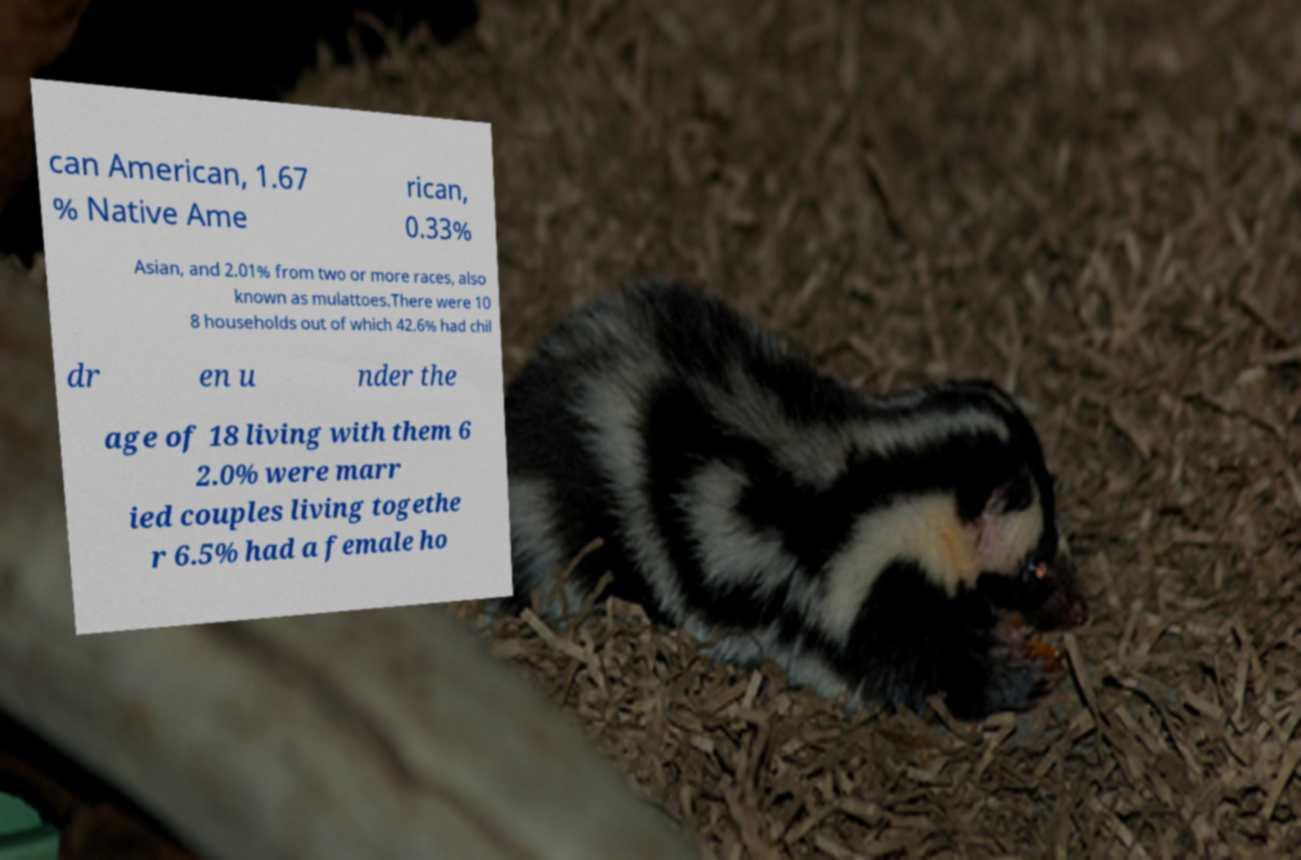For documentation purposes, I need the text within this image transcribed. Could you provide that? can American, 1.67 % Native Ame rican, 0.33% Asian, and 2.01% from two or more races, also known as mulattoes.There were 10 8 households out of which 42.6% had chil dr en u nder the age of 18 living with them 6 2.0% were marr ied couples living togethe r 6.5% had a female ho 